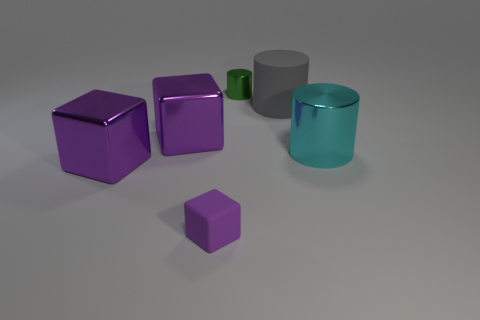How many purple cubes must be subtracted to get 1 purple cubes? 2 Add 3 tiny red cylinders. How many objects exist? 9 Subtract all big cylinders. Subtract all green metallic blocks. How many objects are left? 4 Add 6 large cyan metal objects. How many large cyan metal objects are left? 7 Add 2 gray cylinders. How many gray cylinders exist? 3 Subtract 1 green cylinders. How many objects are left? 5 